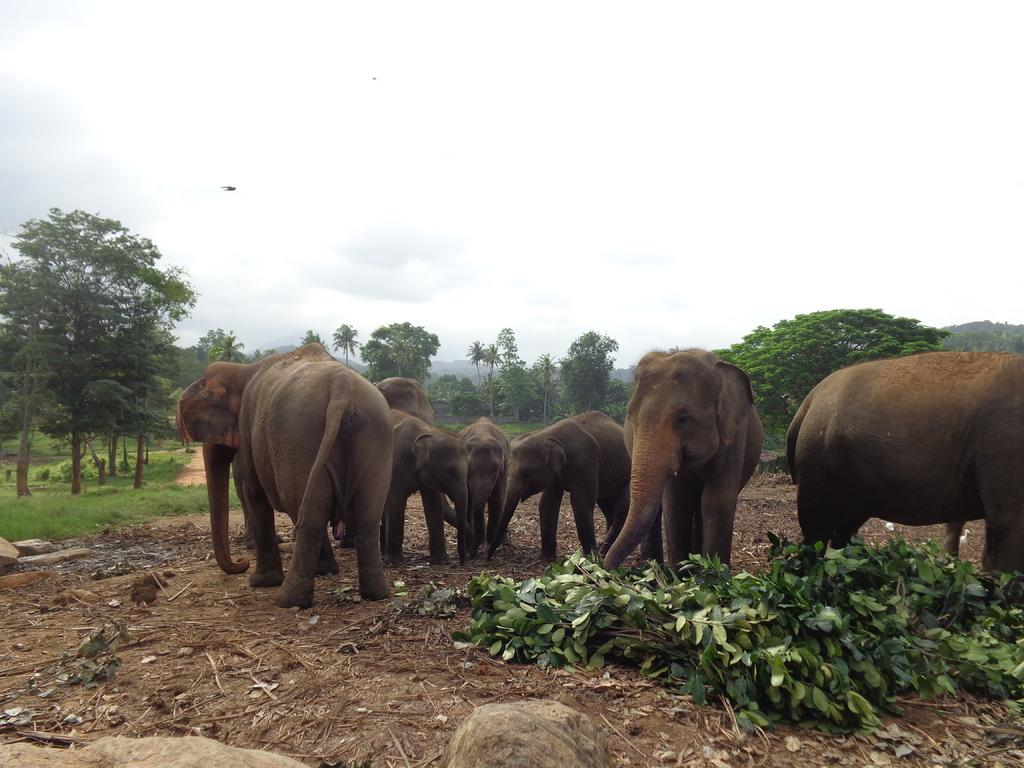What type of vegetation can be seen in the image? There are trees in the image. What animals are present in the image? There are elephants in the image. What is on the ground in the image? There are leaves on the ground in the image. What is visible at the top of the image? The sky is visible at the top of the image. How does the gun increase the efficiency of the sorting process in the image? There is no gun or sorting process present in the image. What type of leaves can be seen on the ground in the image? The provided facts do not specify the type of leaves on the ground, only that there are leaves present. 